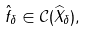Convert formula to latex. <formula><loc_0><loc_0><loc_500><loc_500>\hat { f } _ { \delta } \in \mathcal { C } ( \widehat { X } _ { \delta } ) ,</formula> 